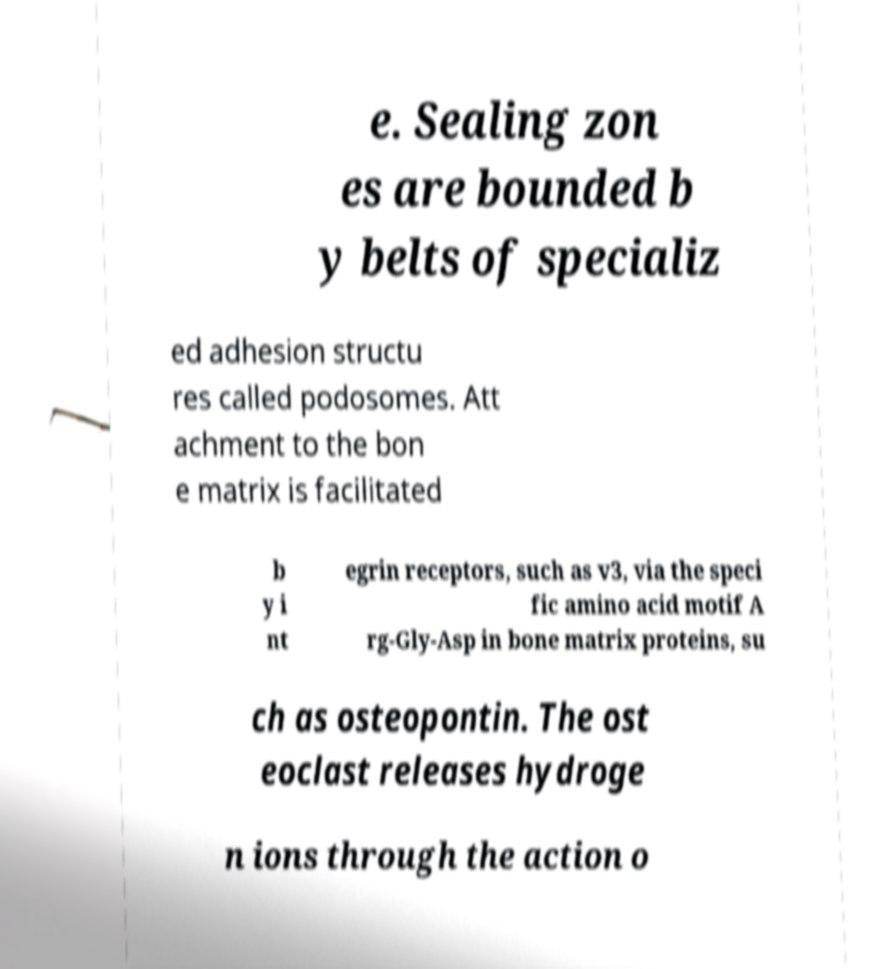Please read and relay the text visible in this image. What does it say? e. Sealing zon es are bounded b y belts of specializ ed adhesion structu res called podosomes. Att achment to the bon e matrix is facilitated b y i nt egrin receptors, such as v3, via the speci fic amino acid motif A rg-Gly-Asp in bone matrix proteins, su ch as osteopontin. The ost eoclast releases hydroge n ions through the action o 